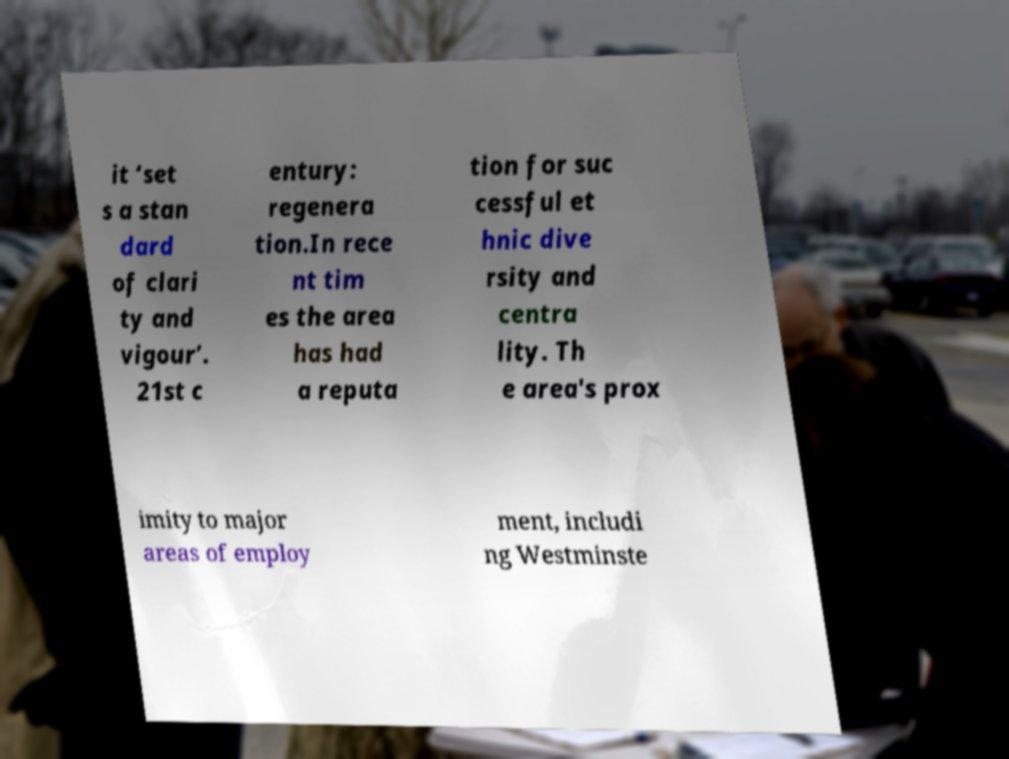For documentation purposes, I need the text within this image transcribed. Could you provide that? it ‘set s a stan dard of clari ty and vigour’. 21st c entury: regenera tion.In rece nt tim es the area has had a reputa tion for suc cessful et hnic dive rsity and centra lity. Th e area's prox imity to major areas of employ ment, includi ng Westminste 